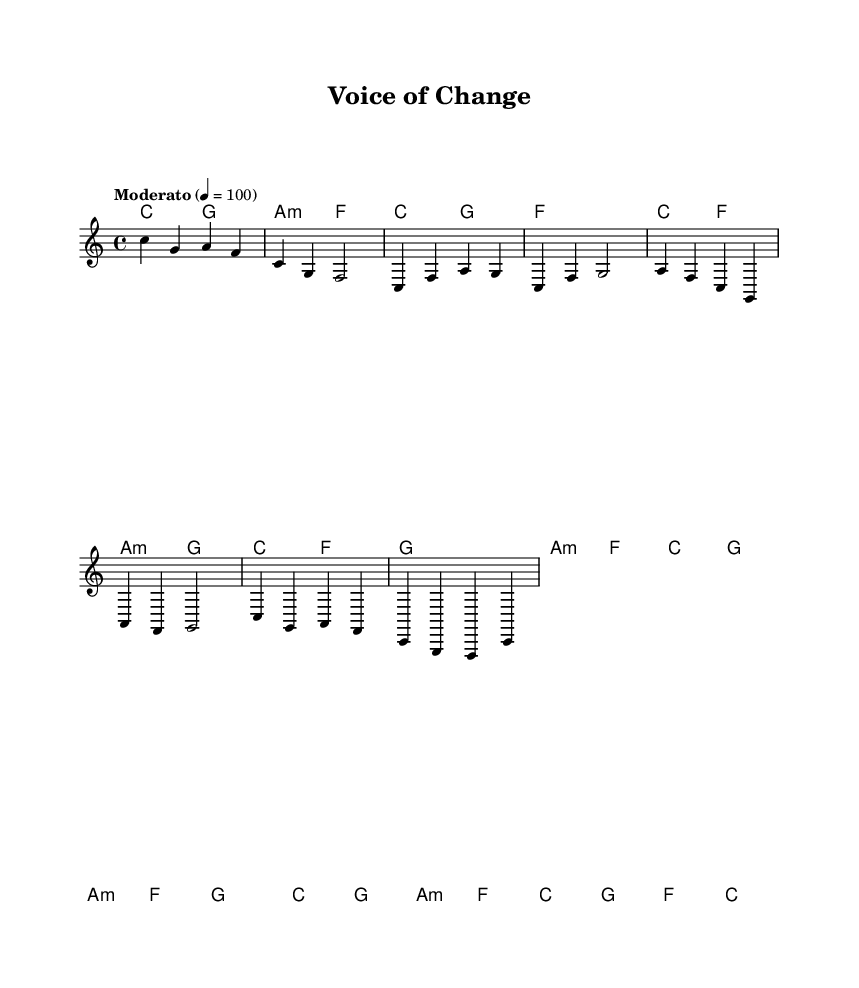What is the key signature of this music? The key signature is indicated at the beginning of the piece and shows C major, which has no sharps or flats.
Answer: C major What is the time signature of this music? The time signature is shown in the beginning and it is 4/4, meaning there are four beats in a measure and a quarter note receives one beat.
Answer: 4/4 What is the tempo marking for this piece? The tempo marking is provided at the start, stating "Moderato" with a metronome marking of 4 = 100, which indicates a moderate speed of 100 beats per minute.
Answer: Moderato How many measures are in the chorus section? To find the number of measures in the chorus, one reviews the music section labeled as the chorus, counting each measure indicates there are four measures.
Answer: 4 What chord is played during the pre-chorus section? The pre-chorus contains two chords, with one specifically being A minor, noted prominently in measures of the pre-chorus.
Answer: A minor What type of musical form does this song follow? The structure of the music can be identified through its sections—intro, verse, pre-chorus, and chorus, which is common in pop music forms.
Answer: Verse-Chorus form 